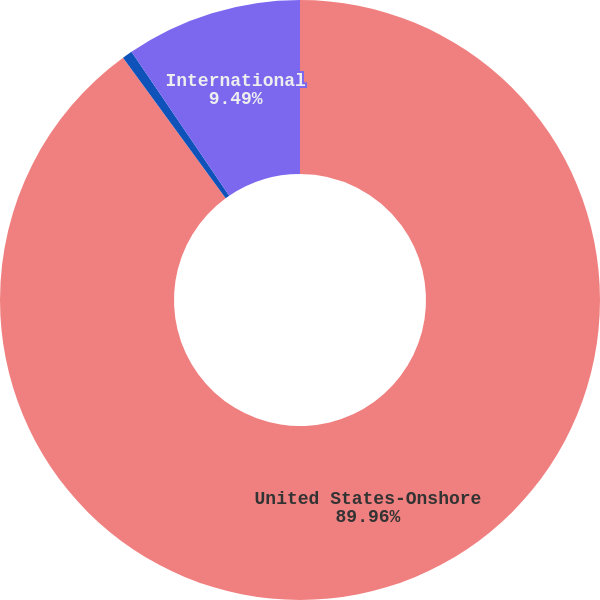<chart> <loc_0><loc_0><loc_500><loc_500><pie_chart><fcel>United States-Onshore<fcel>United States-Offshore<fcel>International<nl><fcel>89.95%<fcel>0.55%<fcel>9.49%<nl></chart> 